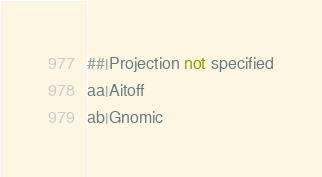Convert code to text. <code><loc_0><loc_0><loc_500><loc_500><_SQL_>##|Projection not specified
aa|Aitoff
ab|Gnomic</code> 